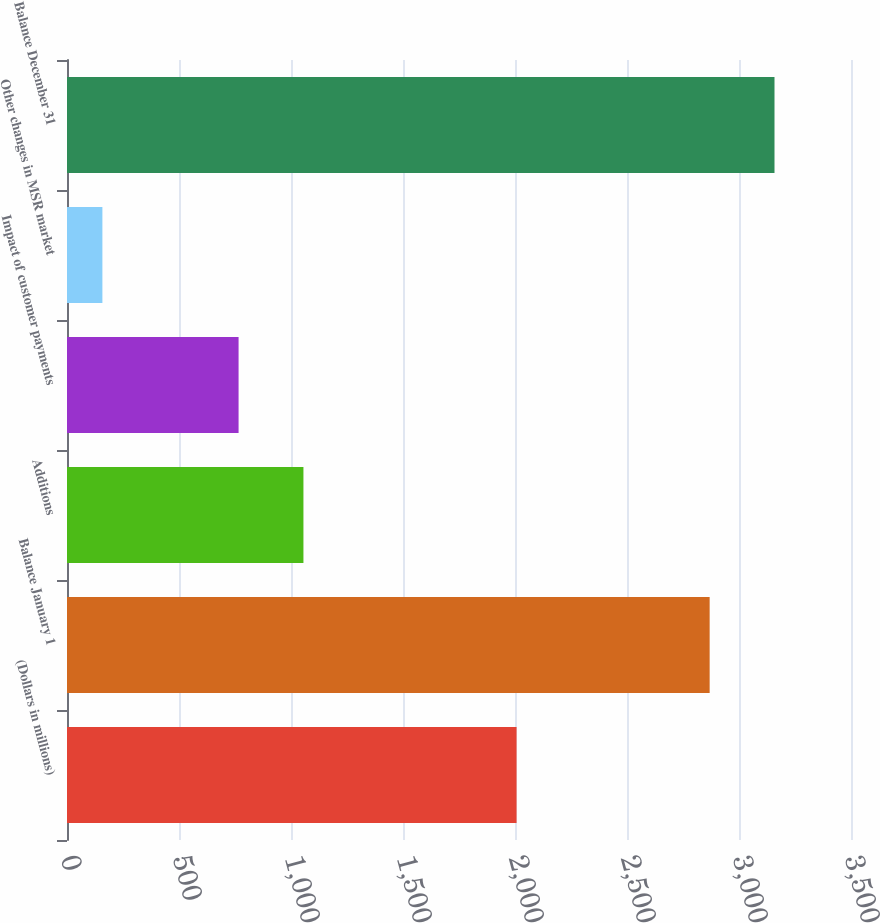Convert chart to OTSL. <chart><loc_0><loc_0><loc_500><loc_500><bar_chart><fcel>(Dollars in millions)<fcel>Balance January 1<fcel>Additions<fcel>Impact of customer payments<fcel>Other changes in MSR market<fcel>Balance December 31<nl><fcel>2007<fcel>2869<fcel>1055.5<fcel>766<fcel>158<fcel>3158.5<nl></chart> 